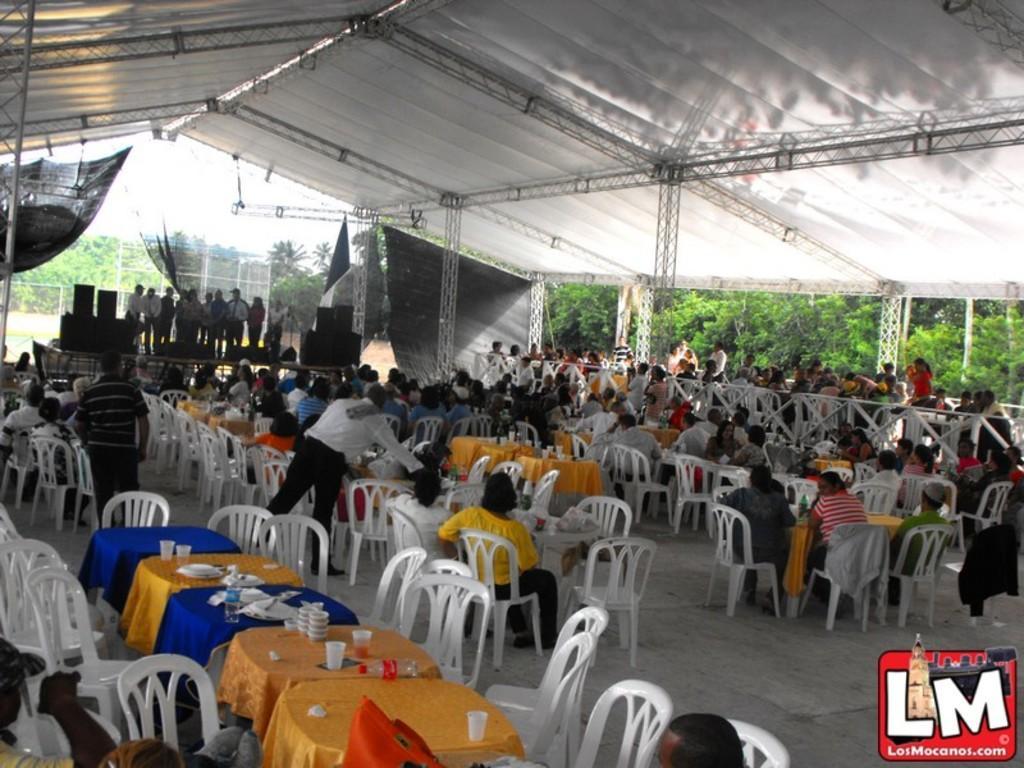Can you describe this image briefly? These are the dining tables and chairs, few people are sitting on this. On the left side there is a stage, few people are standing on it. 